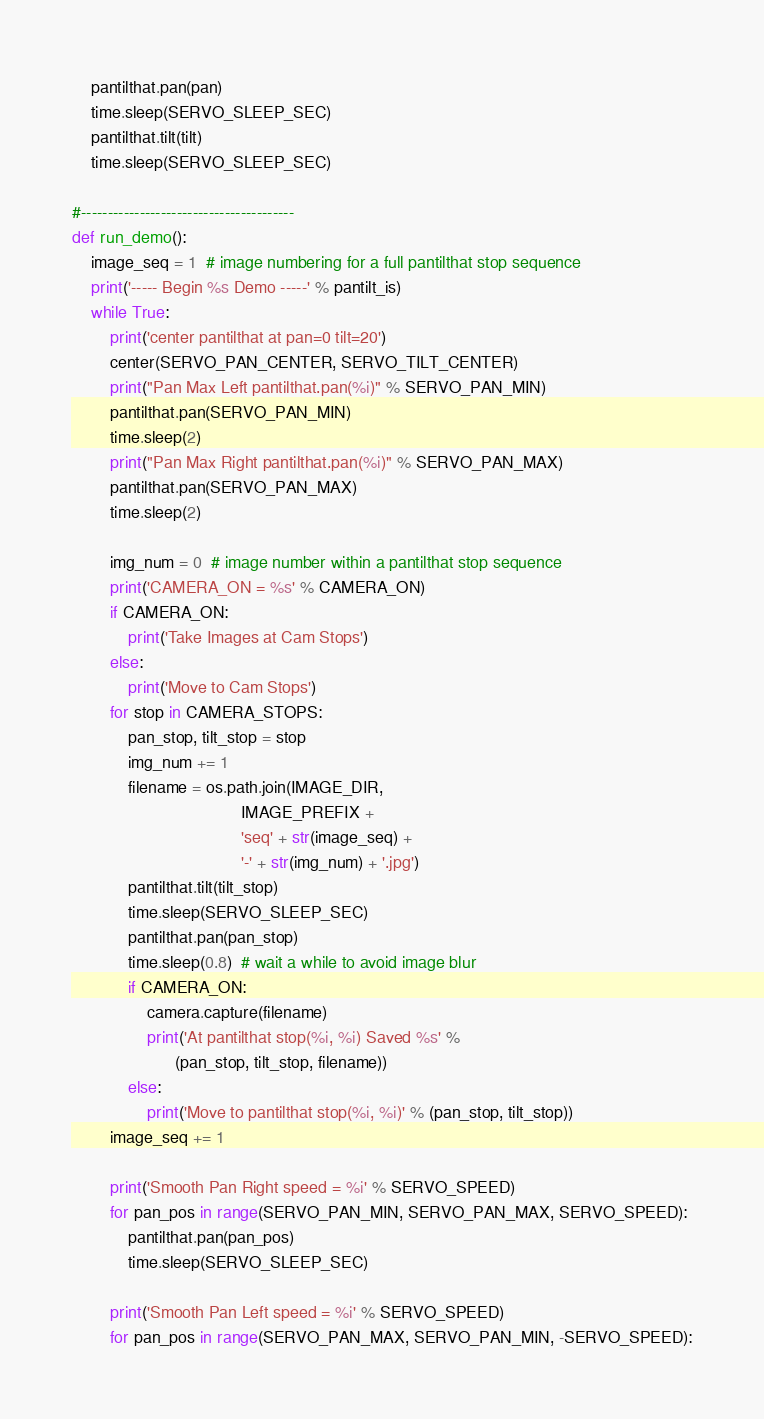Convert code to text. <code><loc_0><loc_0><loc_500><loc_500><_Python_>    pantilthat.pan(pan)
    time.sleep(SERVO_SLEEP_SEC)
    pantilthat.tilt(tilt)
    time.sleep(SERVO_SLEEP_SEC)

#----------------------------------------
def run_demo():
    image_seq = 1  # image numbering for a full pantilthat stop sequence
    print('----- Begin %s Demo -----' % pantilt_is)
    while True:
        print('center pantilthat at pan=0 tilt=20')
        center(SERVO_PAN_CENTER, SERVO_TILT_CENTER)
        print("Pan Max Left pantilthat.pan(%i)" % SERVO_PAN_MIN)
        pantilthat.pan(SERVO_PAN_MIN)
        time.sleep(2)
        print("Pan Max Right pantilthat.pan(%i)" % SERVO_PAN_MAX)
        pantilthat.pan(SERVO_PAN_MAX)
        time.sleep(2)

        img_num = 0  # image number within a pantilthat stop sequence
        print('CAMERA_ON = %s' % CAMERA_ON)
        if CAMERA_ON:
            print('Take Images at Cam Stops')
        else:
            print('Move to Cam Stops')
        for stop in CAMERA_STOPS:
            pan_stop, tilt_stop = stop
            img_num += 1
            filename = os.path.join(IMAGE_DIR,
                                    IMAGE_PREFIX +
                                    'seq' + str(image_seq) +
                                    '-' + str(img_num) + '.jpg')
            pantilthat.tilt(tilt_stop)
            time.sleep(SERVO_SLEEP_SEC)
            pantilthat.pan(pan_stop)
            time.sleep(0.8)  # wait a while to avoid image blur
            if CAMERA_ON:
                camera.capture(filename)
                print('At pantilthat stop(%i, %i) Saved %s' %
                      (pan_stop, tilt_stop, filename))
            else:
                print('Move to pantilthat stop(%i, %i)' % (pan_stop, tilt_stop))
        image_seq += 1

        print('Smooth Pan Right speed = %i' % SERVO_SPEED)
        for pan_pos in range(SERVO_PAN_MIN, SERVO_PAN_MAX, SERVO_SPEED):
            pantilthat.pan(pan_pos)
            time.sleep(SERVO_SLEEP_SEC)

        print('Smooth Pan Left speed = %i' % SERVO_SPEED)
        for pan_pos in range(SERVO_PAN_MAX, SERVO_PAN_MIN, -SERVO_SPEED):</code> 